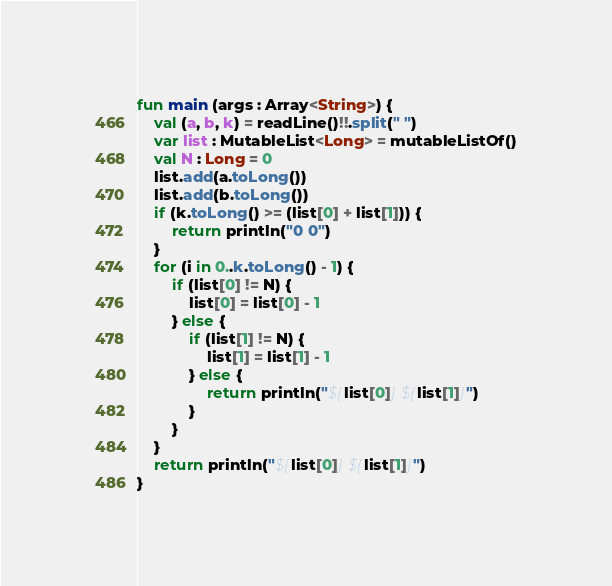Convert code to text. <code><loc_0><loc_0><loc_500><loc_500><_Kotlin_>fun main (args : Array<String>) {
	val (a, b, k) = readLine()!!.split(" ")
	var list : MutableList<Long> = mutableListOf()
	val N : Long = 0
	list.add(a.toLong())
	list.add(b.toLong())
	if (k.toLong() >= (list[0] + list[1])) {
		return println("0 0")
	}
	for (i in 0..k.toLong() - 1) {
		if (list[0] != N) {
			list[0] = list[0] - 1
		} else {
			if (list[1] != N) {
				list[1] = list[1] - 1
			} else {
				return println("${list[0]} ${list[1]}")
			}
		}
	}
	return println("${list[0]} ${list[1]}")
}</code> 